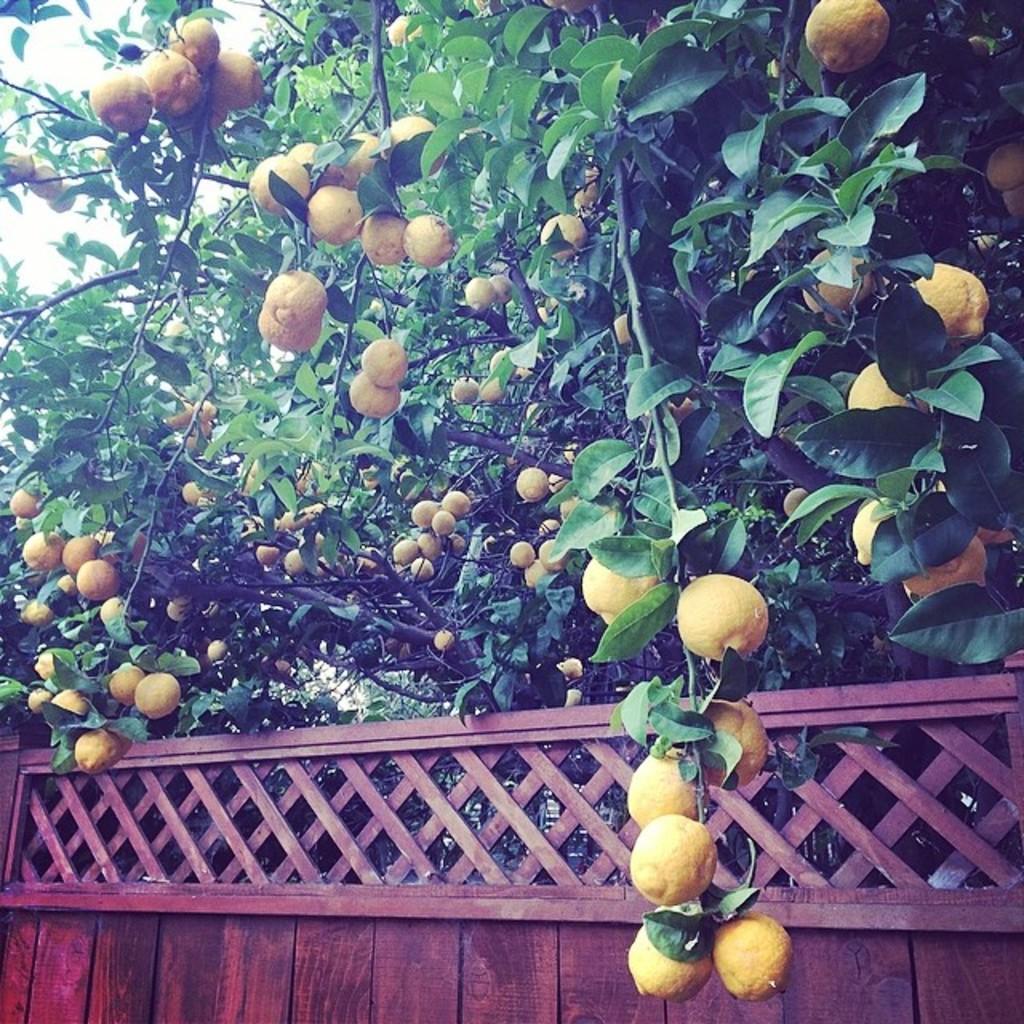Describe this image in one or two sentences. In this image we can see fruits and trees. At the bottom there is a wall. In the background we can see sky. 